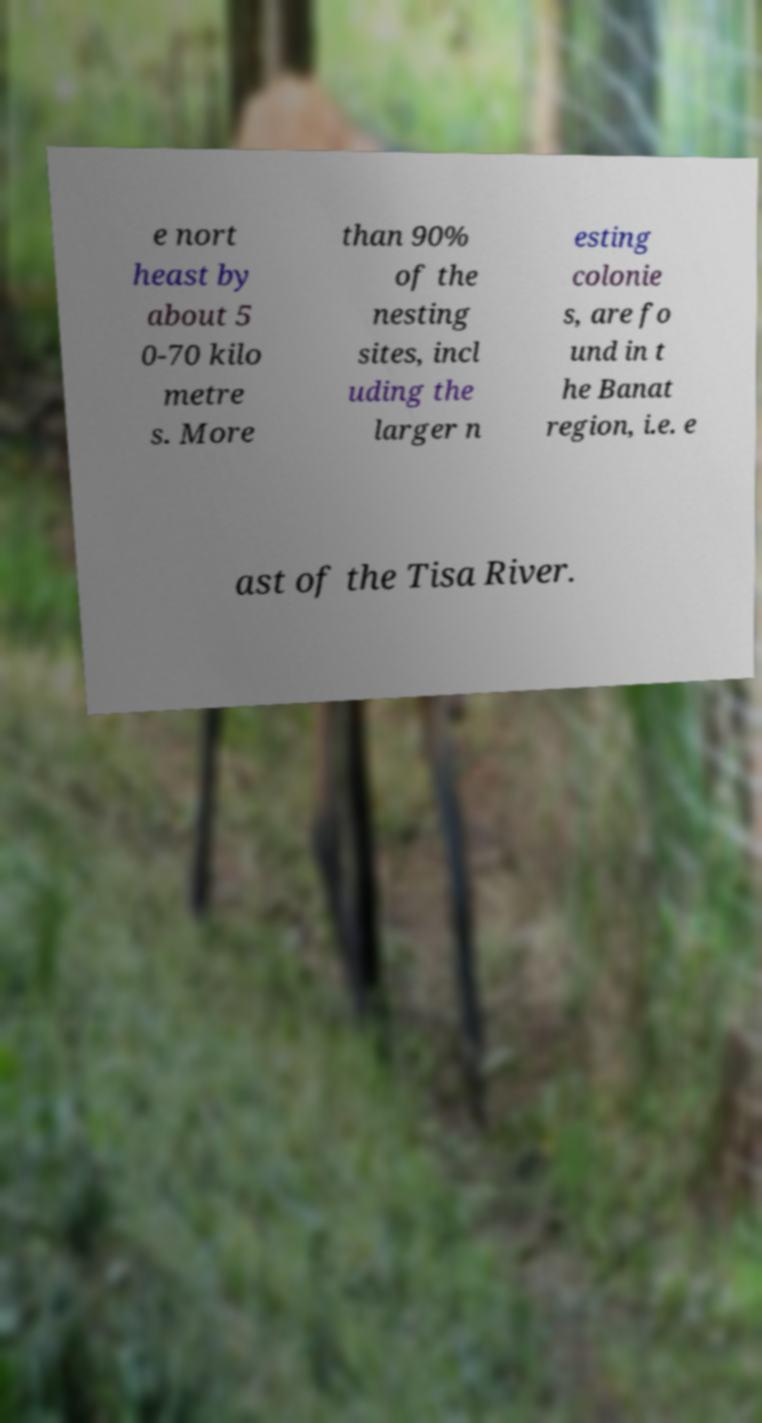I need the written content from this picture converted into text. Can you do that? e nort heast by about 5 0-70 kilo metre s. More than 90% of the nesting sites, incl uding the larger n esting colonie s, are fo und in t he Banat region, i.e. e ast of the Tisa River. 